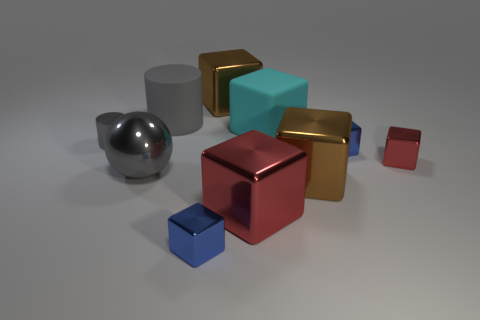Subtract all matte blocks. How many blocks are left? 6 Subtract all brown cubes. How many cubes are left? 5 Subtract 2 blocks. How many blocks are left? 5 Subtract all gray blocks. Subtract all brown cylinders. How many blocks are left? 7 Subtract all spheres. How many objects are left? 9 Subtract 0 cyan balls. How many objects are left? 10 Subtract all red metal things. Subtract all cylinders. How many objects are left? 6 Add 8 big cyan blocks. How many big cyan blocks are left? 9 Add 9 big red matte spheres. How many big red matte spheres exist? 9 